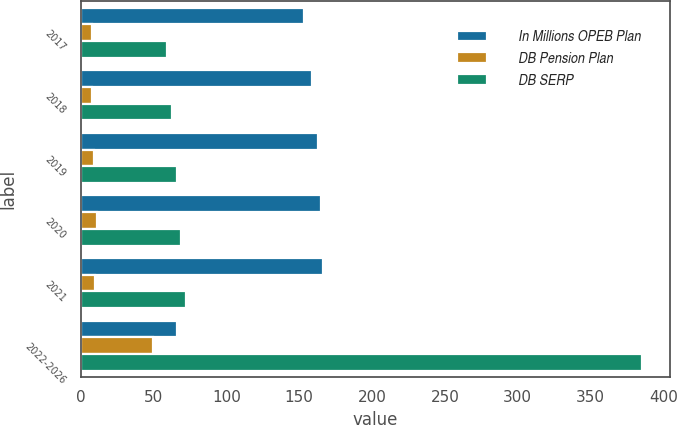Convert chart to OTSL. <chart><loc_0><loc_0><loc_500><loc_500><stacked_bar_chart><ecel><fcel>2017<fcel>2018<fcel>2019<fcel>2020<fcel>2021<fcel>2022-2026<nl><fcel>In Millions OPEB Plan<fcel>153<fcel>159<fcel>163<fcel>165<fcel>166<fcel>66<nl><fcel>DB Pension Plan<fcel>8<fcel>8<fcel>9<fcel>11<fcel>10<fcel>50<nl><fcel>DB SERP<fcel>59<fcel>63<fcel>66<fcel>69<fcel>72<fcel>385<nl></chart> 